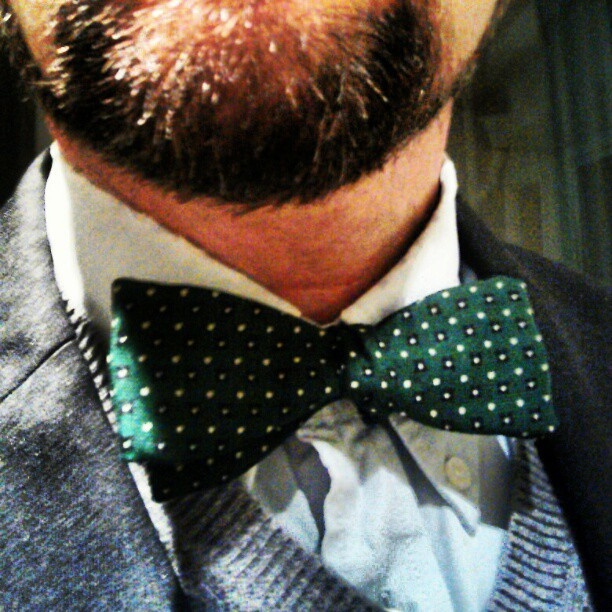Describe the objects in this image and their specific colors. I can see people in black, maroon, lightgray, gray, and darkgray tones and tie in maroon, black, teal, darkgreen, and gray tones in this image. 